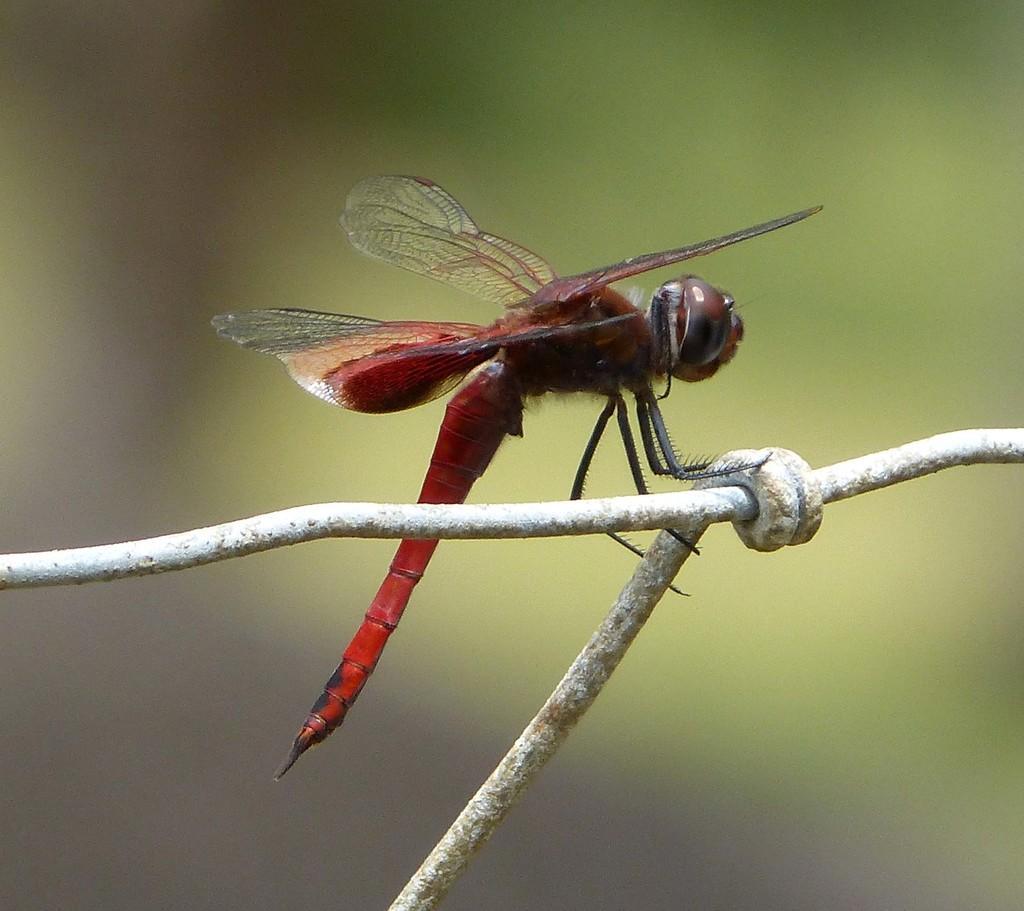Could you give a brief overview of what you see in this image? In this image there is an insect in the center which is on the rod and the background is blurry. 